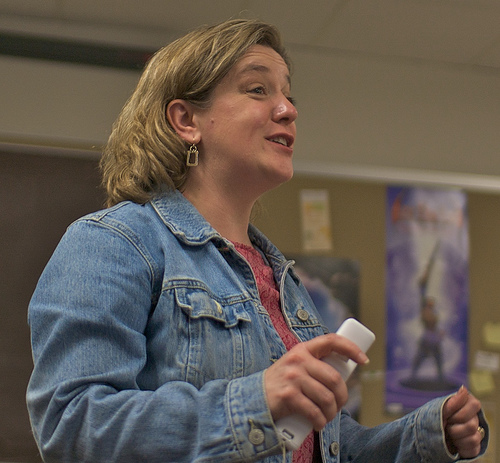<image>What is her name? I don't know her name. It could be any name like 'karen', 'alice', 'jean', 'linda', 'jenna', 'tammy', 'sally', 'lisa', or 'jane'. What does the woman have on her shoulder's? The woman may have a jacket or a coat on her shoulder, or she might have nothing. What is her name? I am not sure what her name is. It can be Karen, Alice, Jean, Linda, Jenna, Tammy, Sally, Lisa, or Jane. What does the woman have on her shoulder's? I don't know what the woman has on her shoulder's. It could be a jacket or a coat. 